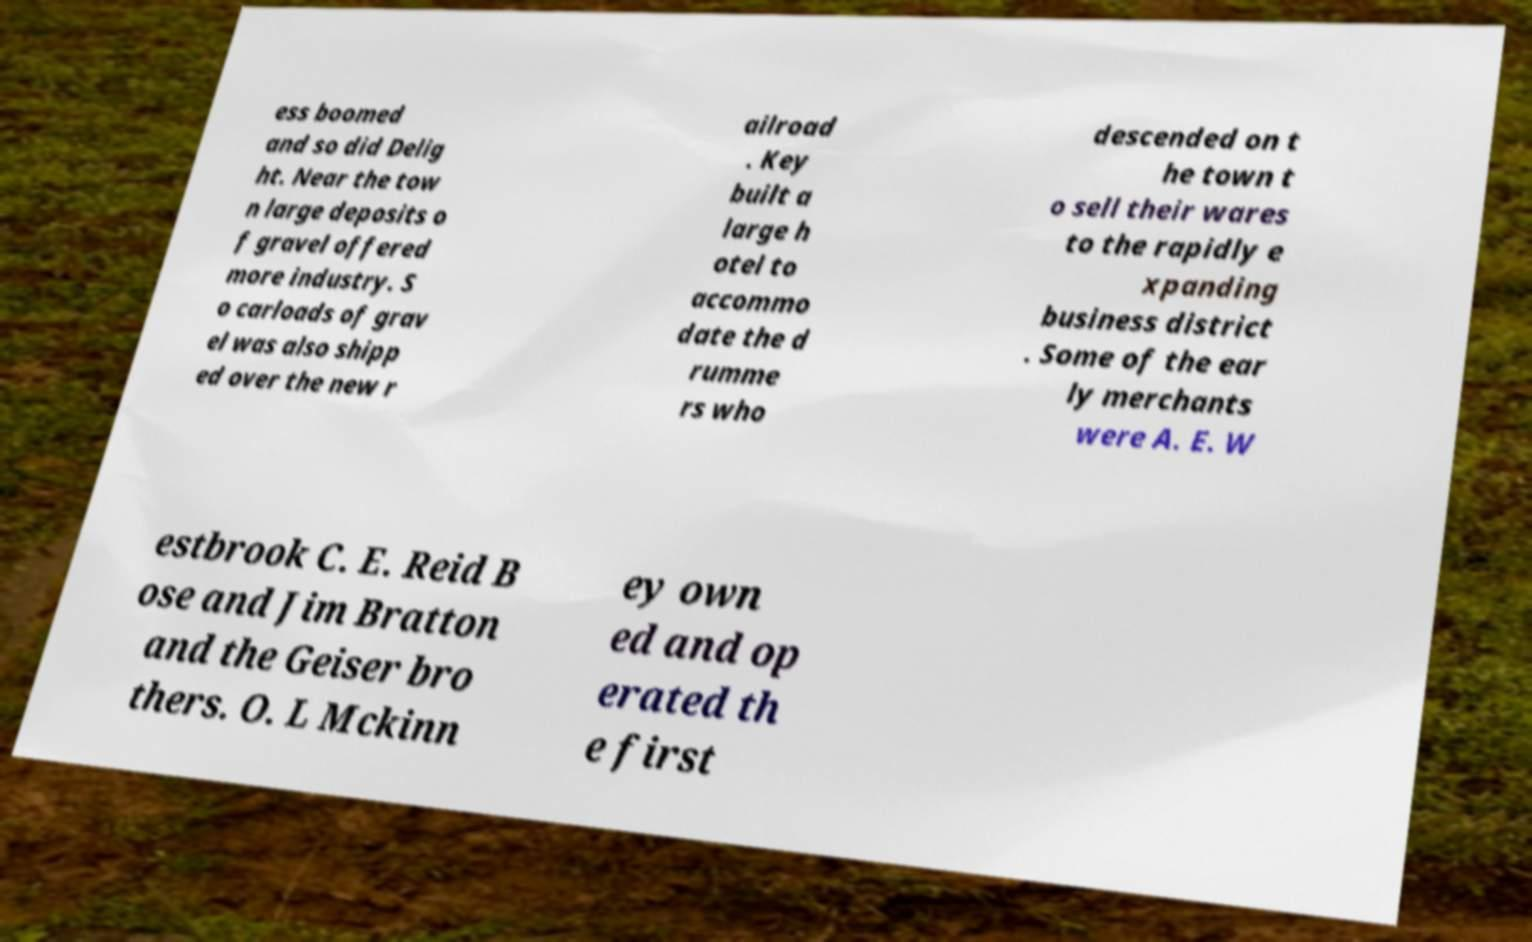Could you assist in decoding the text presented in this image and type it out clearly? ess boomed and so did Delig ht. Near the tow n large deposits o f gravel offered more industry. S o carloads of grav el was also shipp ed over the new r ailroad . Key built a large h otel to accommo date the d rumme rs who descended on t he town t o sell their wares to the rapidly e xpanding business district . Some of the ear ly merchants were A. E. W estbrook C. E. Reid B ose and Jim Bratton and the Geiser bro thers. O. L Mckinn ey own ed and op erated th e first 